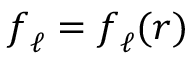Convert formula to latex. <formula><loc_0><loc_0><loc_500><loc_500>f _ { \ell } = f _ { \ell } ( r )</formula> 